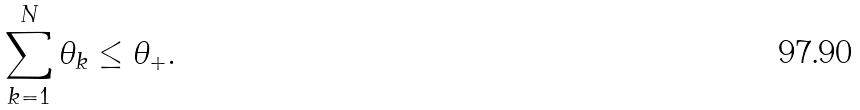Convert formula to latex. <formula><loc_0><loc_0><loc_500><loc_500>\sum _ { k = 1 } ^ { N } \theta _ { k } \leq \theta _ { + } .</formula> 